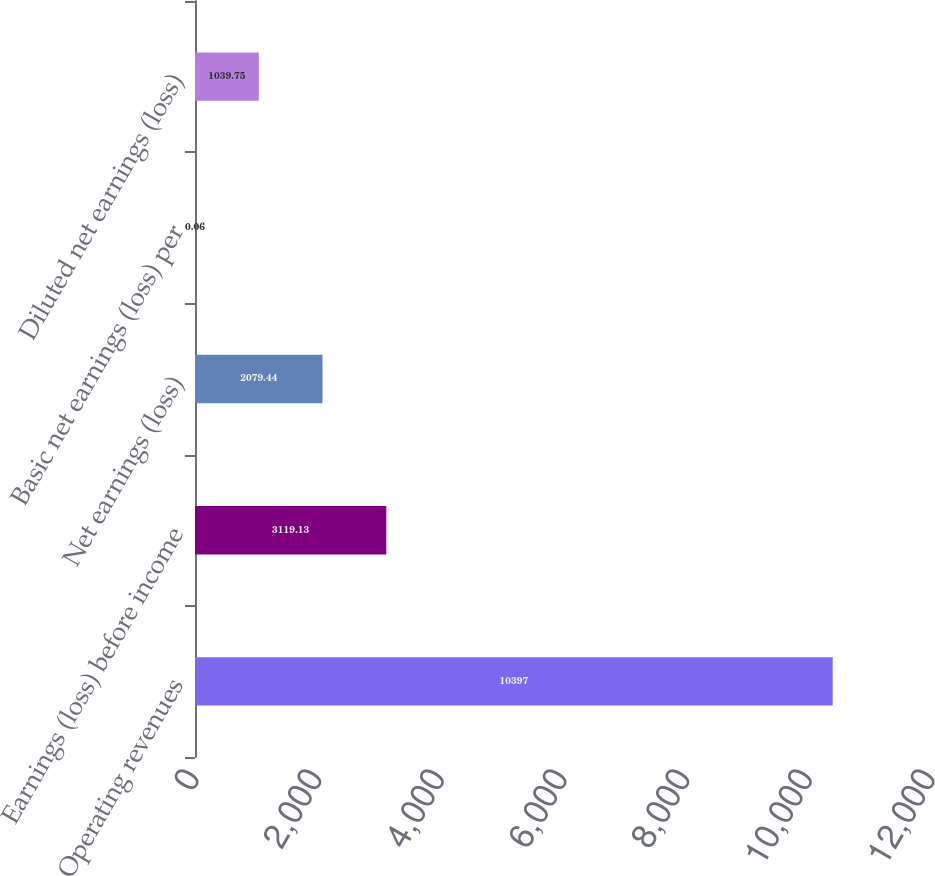Convert chart to OTSL. <chart><loc_0><loc_0><loc_500><loc_500><bar_chart><fcel>Operating revenues<fcel>Earnings (loss) before income<fcel>Net earnings (loss)<fcel>Basic net earnings (loss) per<fcel>Diluted net earnings (loss)<nl><fcel>10397<fcel>3119.13<fcel>2079.44<fcel>0.06<fcel>1039.75<nl></chart> 